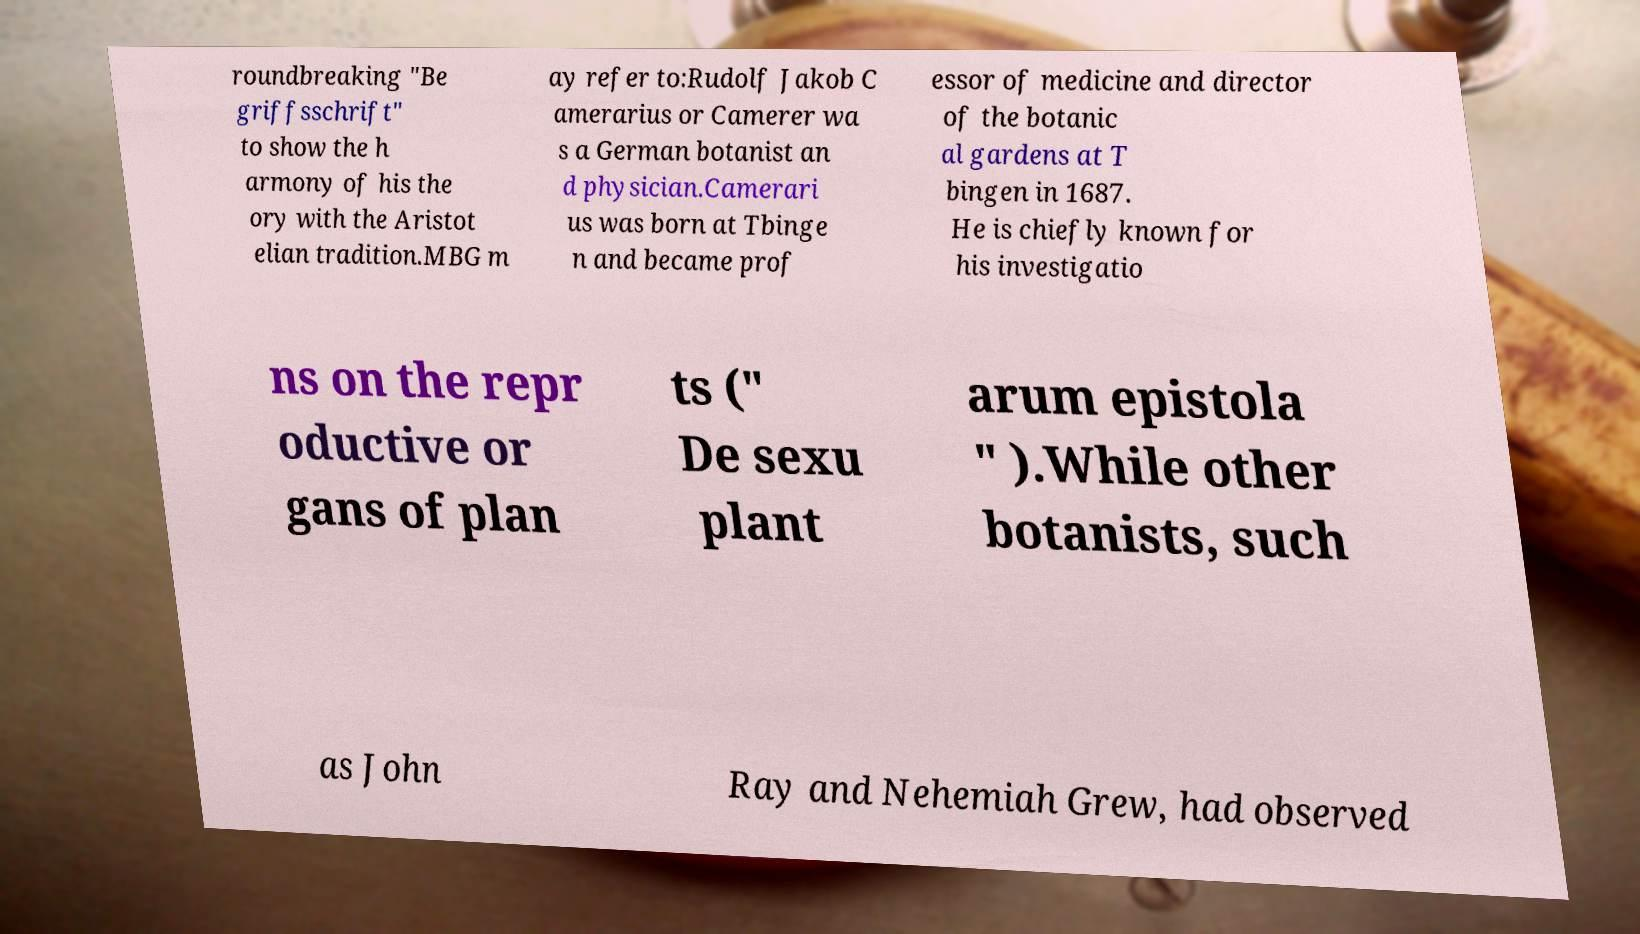For documentation purposes, I need the text within this image transcribed. Could you provide that? roundbreaking "Be griffsschrift" to show the h armony of his the ory with the Aristot elian tradition.MBG m ay refer to:Rudolf Jakob C amerarius or Camerer wa s a German botanist an d physician.Camerari us was born at Tbinge n and became prof essor of medicine and director of the botanic al gardens at T bingen in 1687. He is chiefly known for his investigatio ns on the repr oductive or gans of plan ts (" De sexu plant arum epistola " ).While other botanists, such as John Ray and Nehemiah Grew, had observed 